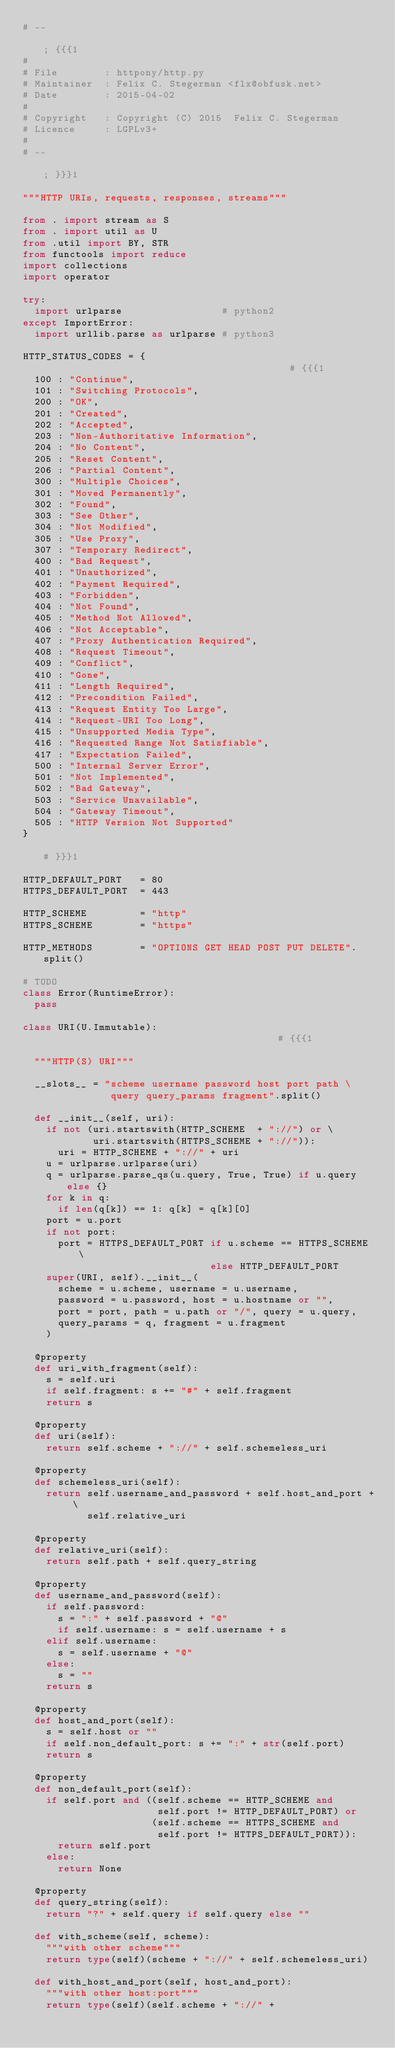Convert code to text. <code><loc_0><loc_0><loc_500><loc_500><_Python_># --                                                            ; {{{1
#
# File        : httpony/http.py
# Maintainer  : Felix C. Stegerman <flx@obfusk.net>
# Date        : 2015-04-02
#
# Copyright   : Copyright (C) 2015  Felix C. Stegerman
# Licence     : LGPLv3+
#
# --                                                            ; }}}1

"""HTTP URIs, requests, responses, streams"""

from . import stream as S
from . import util as U
from .util import BY, STR
from functools import reduce
import collections
import operator

try:
  import urlparse                 # python2
except ImportError:
  import urllib.parse as urlparse # python3

HTTP_STATUS_CODES = {                                           # {{{1
  100 : "Continue",
  101 : "Switching Protocols",
  200 : "OK",
  201 : "Created",
  202 : "Accepted",
  203 : "Non-Authoritative Information",
  204 : "No Content",
  205 : "Reset Content",
  206 : "Partial Content",
  300 : "Multiple Choices",
  301 : "Moved Permanently",
  302 : "Found",
  303 : "See Other",
  304 : "Not Modified",
  305 : "Use Proxy",
  307 : "Temporary Redirect",
  400 : "Bad Request",
  401 : "Unauthorized",
  402 : "Payment Required",
  403 : "Forbidden",
  404 : "Not Found",
  405 : "Method Not Allowed",
  406 : "Not Acceptable",
  407 : "Proxy Authentication Required",
  408 : "Request Timeout",
  409 : "Conflict",
  410 : "Gone",
  411 : "Length Required",
  412 : "Precondition Failed",
  413 : "Request Entity Too Large",
  414 : "Request-URI Too Long",
  415 : "Unsupported Media Type",
  416 : "Requested Range Not Satisfiable",
  417 : "Expectation Failed",
  500 : "Internal Server Error",
  501 : "Not Implemented",
  502 : "Bad Gateway",
  503 : "Service Unavailable",
  504 : "Gateway Timeout",
  505 : "HTTP Version Not Supported"
}                                                               # }}}1

HTTP_DEFAULT_PORT   = 80
HTTPS_DEFAULT_PORT  = 443

HTTP_SCHEME         = "http"
HTTPS_SCHEME        = "https"

HTTP_METHODS        = "OPTIONS GET HEAD POST PUT DELETE".split()

# TODO
class Error(RuntimeError):
  pass

class URI(U.Immutable):                                         # {{{1

  """HTTP(S) URI"""

  __slots__ = "scheme username password host port path \
               query query_params fragment".split()

  def __init__(self, uri):
    if not (uri.startswith(HTTP_SCHEME  + "://") or \
            uri.startswith(HTTPS_SCHEME + "://")):
      uri = HTTP_SCHEME + "://" + uri
    u = urlparse.urlparse(uri)
    q = urlparse.parse_qs(u.query, True, True) if u.query else {}
    for k in q:
      if len(q[k]) == 1: q[k] = q[k][0]
    port = u.port
    if not port:
      port = HTTPS_DEFAULT_PORT if u.scheme == HTTPS_SCHEME \
                                else HTTP_DEFAULT_PORT
    super(URI, self).__init__(
      scheme = u.scheme, username = u.username,
      password = u.password, host = u.hostname or "",
      port = port, path = u.path or "/", query = u.query,
      query_params = q, fragment = u.fragment
    )

  @property
  def uri_with_fragment(self):
    s = self.uri
    if self.fragment: s += "#" + self.fragment
    return s

  @property
  def uri(self):
    return self.scheme + "://" + self.schemeless_uri

  @property
  def schemeless_uri(self):
    return self.username_and_password + self.host_and_port + \
           self.relative_uri

  @property
  def relative_uri(self):
    return self.path + self.query_string

  @property
  def username_and_password(self):
    if self.password:
      s = ":" + self.password + "@"
      if self.username: s = self.username + s
    elif self.username:
      s = self.username + "@"
    else:
      s = ""
    return s

  @property
  def host_and_port(self):
    s = self.host or ""
    if self.non_default_port: s += ":" + str(self.port)
    return s

  @property
  def non_default_port(self):
    if self.port and ((self.scheme == HTTP_SCHEME and
                       self.port != HTTP_DEFAULT_PORT) or
                      (self.scheme == HTTPS_SCHEME and
                       self.port != HTTPS_DEFAULT_PORT)):
      return self.port
    else:
      return None

  @property
  def query_string(self):
    return "?" + self.query if self.query else ""

  def with_scheme(self, scheme):
    """with other scheme"""
    return type(self)(scheme + "://" + self.schemeless_uri)

  def with_host_and_port(self, host_and_port):
    """with other host:port"""
    return type(self)(self.scheme + "://" +</code> 